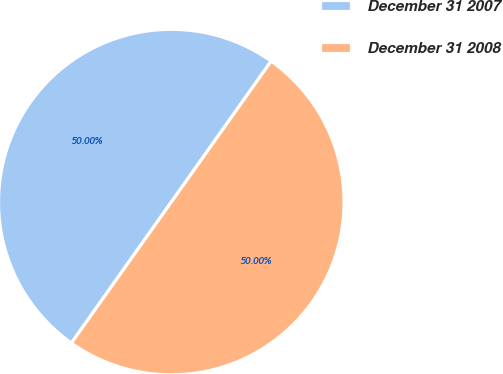Convert chart. <chart><loc_0><loc_0><loc_500><loc_500><pie_chart><fcel>December 31 2007<fcel>December 31 2008<nl><fcel>50.0%<fcel>50.0%<nl></chart> 